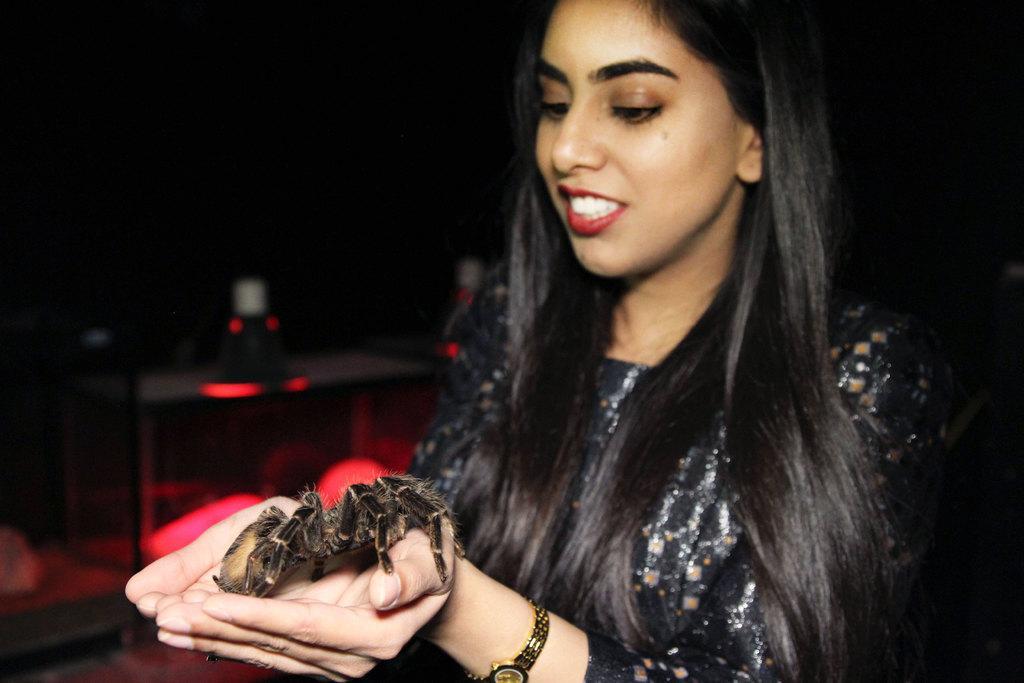In one or two sentences, can you explain what this image depicts? In this image in front there is a woman holding a Scorpio. Behind her there is a table with some object on it. 